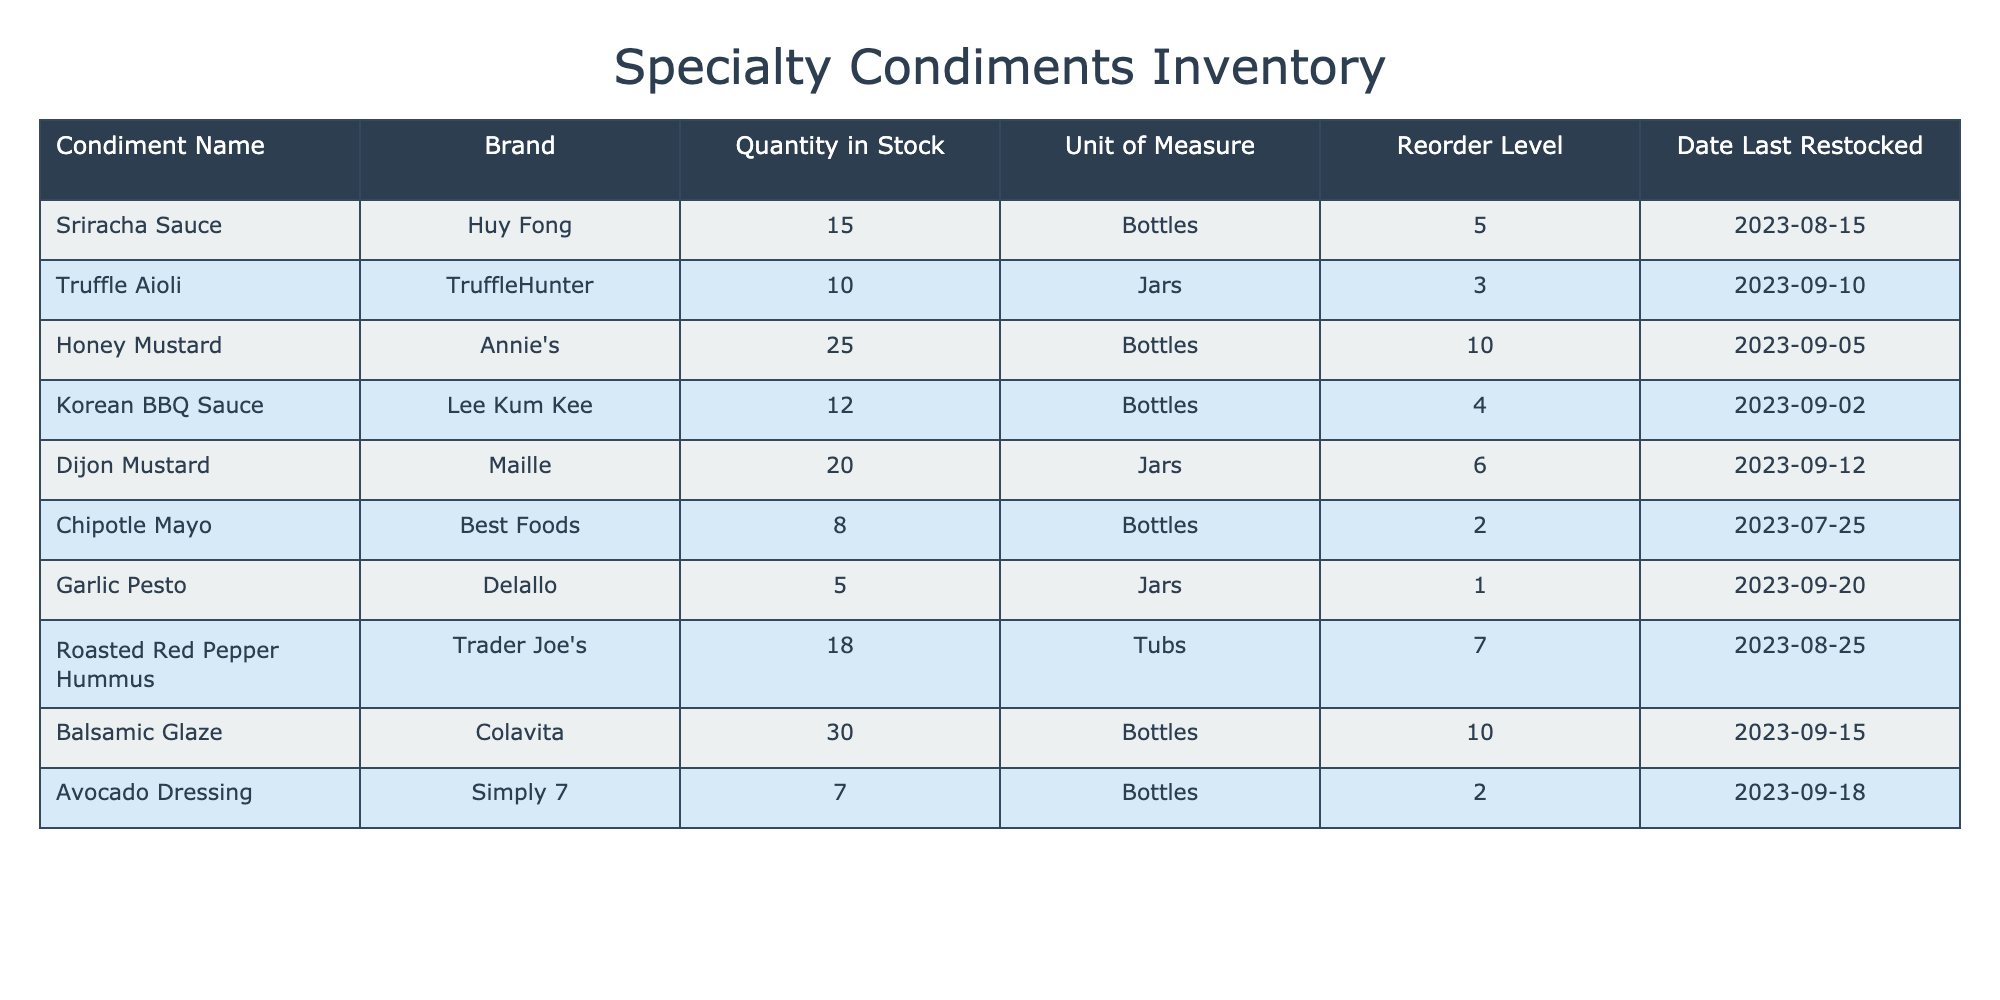What is the quantity of Sriracha Sauce in stock? The table shows that the quantity of Sriracha Sauce in stock is listed under the "Quantity in Stock" column for Huy Fong, which is 15.
Answer: 15 How many bottles of Honey Mustard do we have? Looking at the table, Honey Mustard by Annie's has a "Quantity in Stock" of 25 bottles.
Answer: 25 What is the total number of jars of condiments currently in stock? To find the total jars in stock, we sum the quantities from the "Quantity in Stock" column for all jars: Truffle Aioli (10) + Dijon Mustard (20) + Garlic Pesto (5) = 35 jars.
Answer: 35 Is there a reorder level for Asian-style condiments? The table shows Korean BBQ Sauce has a reorder level of 4, which indicates that it does have a reorder level, making this statement true.
Answer: Yes Are there any condiments in stock that are near their reorder levels? Comparing the "Quantity in Stock" with the "Reorder Level," Chipotle Mayo (8) is only 6 above its reorder level of 2, indicating it's near reorder. Thus, the answer is true.
Answer: Yes Which condiment has the highest stock level? By examining the "Quantity in Stock," Balsamic Glaze has the highest inventory at 30 bottles, surpassing all others listed in the table.
Answer: Balsamic Glaze What is the average quantity of stock across all condiments? To find the average, we first calculate the sum of all quantities: 15 + 10 + 25 + 12 + 20 + 8 + 5 + 18 + 30 + 7 = 150. There are 10 items, thus the average quantity is 150/10 = 15.
Answer: 15 Which condiment should be restocked based on the current levels? The table indicates Garlic Pesto has a stock of 5 units, while the reorder level is 1, indicating it should be restocked since it is above the reorder level but not significantly high.
Answer: Garlic Pesto 